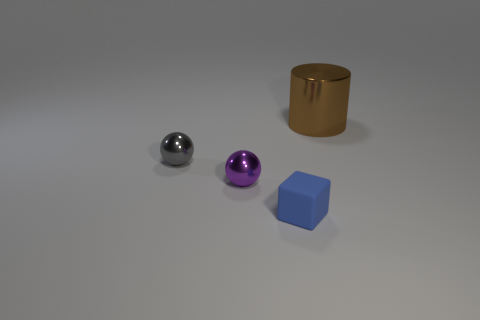Is there a gray ball that has the same material as the big brown thing?
Offer a terse response. Yes. What number of purple things are shiny spheres or small rubber things?
Your response must be concise. 1. There is a object that is both behind the purple sphere and left of the rubber block; what size is it?
Your answer should be compact. Small. Is the number of blue things that are behind the big brown metal cylinder greater than the number of tiny blue metal spheres?
Offer a very short reply. No. How many spheres are either large brown things or cyan matte things?
Provide a succinct answer. 0. The thing that is on the right side of the purple object and in front of the small gray thing has what shape?
Your response must be concise. Cube. Are there the same number of metal balls to the left of the gray metal ball and blue blocks left of the purple sphere?
Give a very brief answer. Yes. What number of objects are blue rubber things or big metallic cylinders?
Your answer should be compact. 2. What is the color of the other ball that is the same size as the gray shiny sphere?
Make the answer very short. Purple. What number of objects are either metallic objects that are in front of the large shiny thing or things that are on the left side of the big cylinder?
Offer a terse response. 3. 